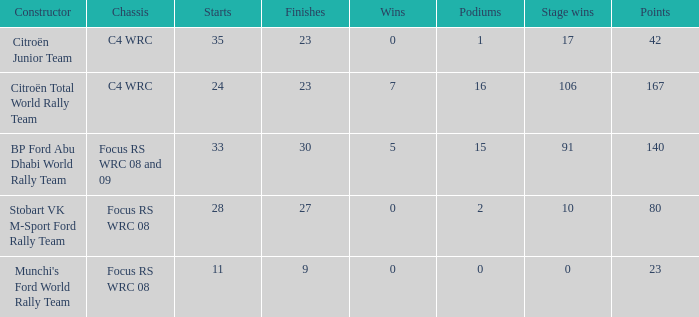What is the average wins when the podiums is more than 1, points is 80 and starts is less than 28? None. 